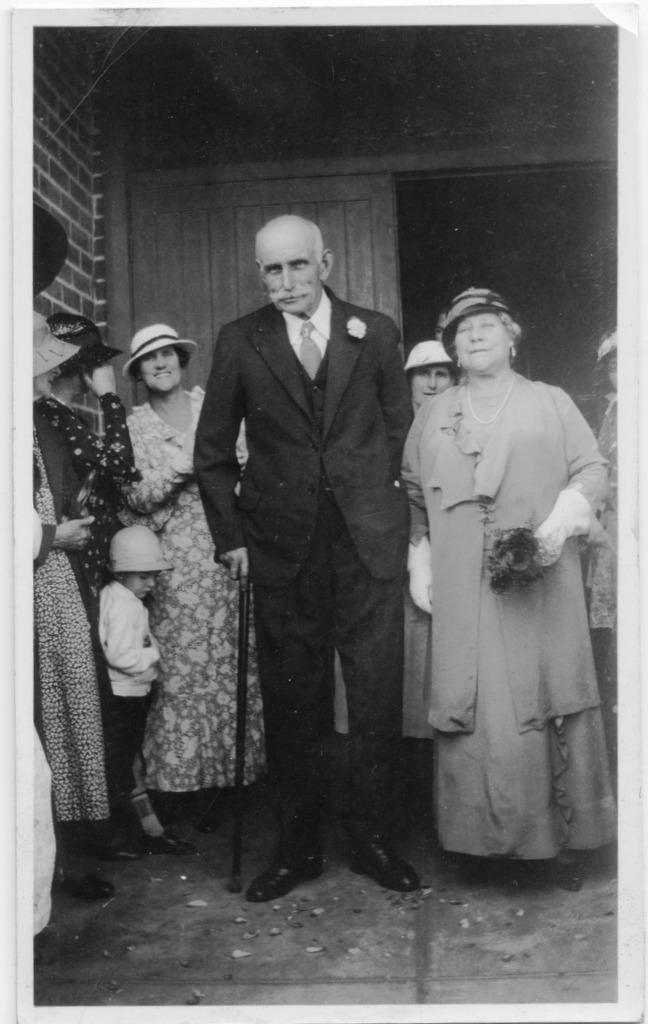What is the color scheme of the image? The image is black and white. What can be seen in the image? There is a group of people standing in the image. What is visible in the background of the image? There is a wooden door in the background of the image. Can you see a guitar being played by one of the people in the image? There is no guitar present in the image. Is there a snake slithering across the wooden door in the background? There is no snake visible in the image. 